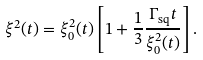<formula> <loc_0><loc_0><loc_500><loc_500>\xi ^ { 2 } ( t ) = \xi ^ { 2 } _ { 0 } ( t ) \left [ 1 + \frac { 1 } { 3 } \frac { \Gamma _ { \text {sq} } t } { \xi ^ { 2 } _ { 0 } ( t ) } \right ] .</formula> 